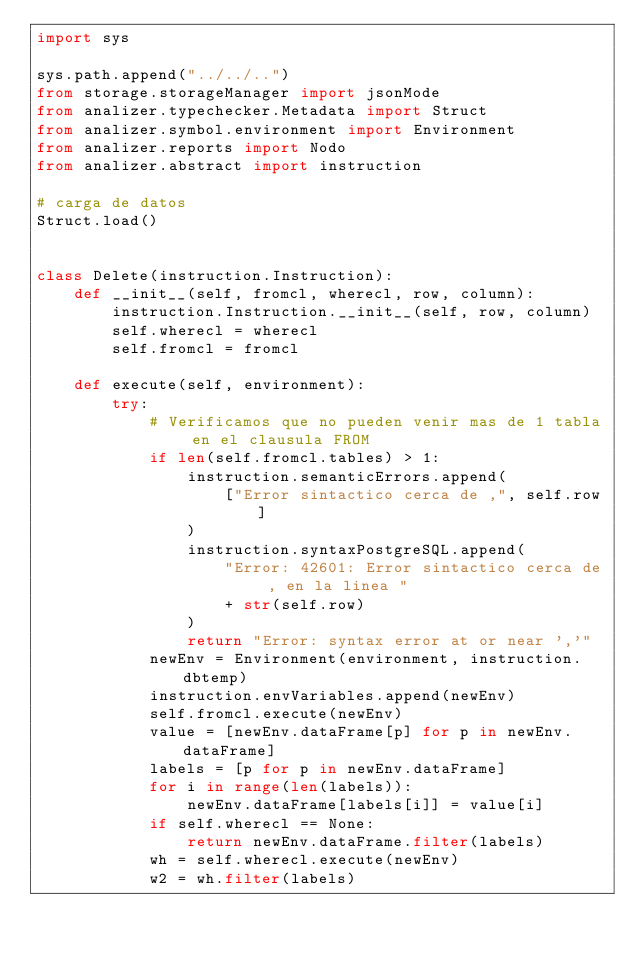<code> <loc_0><loc_0><loc_500><loc_500><_Python_>import sys

sys.path.append("../../..")
from storage.storageManager import jsonMode
from analizer.typechecker.Metadata import Struct
from analizer.symbol.environment import Environment
from analizer.reports import Nodo
from analizer.abstract import instruction

# carga de datos
Struct.load()


class Delete(instruction.Instruction):
    def __init__(self, fromcl, wherecl, row, column):
        instruction.Instruction.__init__(self, row, column)
        self.wherecl = wherecl
        self.fromcl = fromcl

    def execute(self, environment):
        try:
            # Verificamos que no pueden venir mas de 1 tabla en el clausula FROM
            if len(self.fromcl.tables) > 1:
                instruction.semanticErrors.append(
                    ["Error sintactico cerca de ,", self.row]
                )
                instruction.syntaxPostgreSQL.append(
                    "Error: 42601: Error sintactico cerca de , en la linea "
                    + str(self.row)
                )
                return "Error: syntax error at or near ','"
            newEnv = Environment(environment, instruction.dbtemp)
            instruction.envVariables.append(newEnv)
            self.fromcl.execute(newEnv)
            value = [newEnv.dataFrame[p] for p in newEnv.dataFrame]
            labels = [p for p in newEnv.dataFrame]
            for i in range(len(labels)):
                newEnv.dataFrame[labels[i]] = value[i]
            if self.wherecl == None:
                return newEnv.dataFrame.filter(labels)
            wh = self.wherecl.execute(newEnv)
            w2 = wh.filter(labels)</code> 